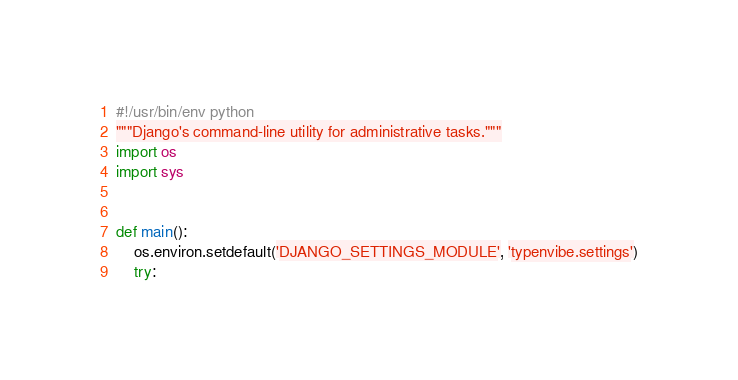Convert code to text. <code><loc_0><loc_0><loc_500><loc_500><_Python_>#!/usr/bin/env python
"""Django's command-line utility for administrative tasks."""
import os
import sys


def main():
    os.environ.setdefault('DJANGO_SETTINGS_MODULE', 'typenvibe.settings')
    try:</code> 